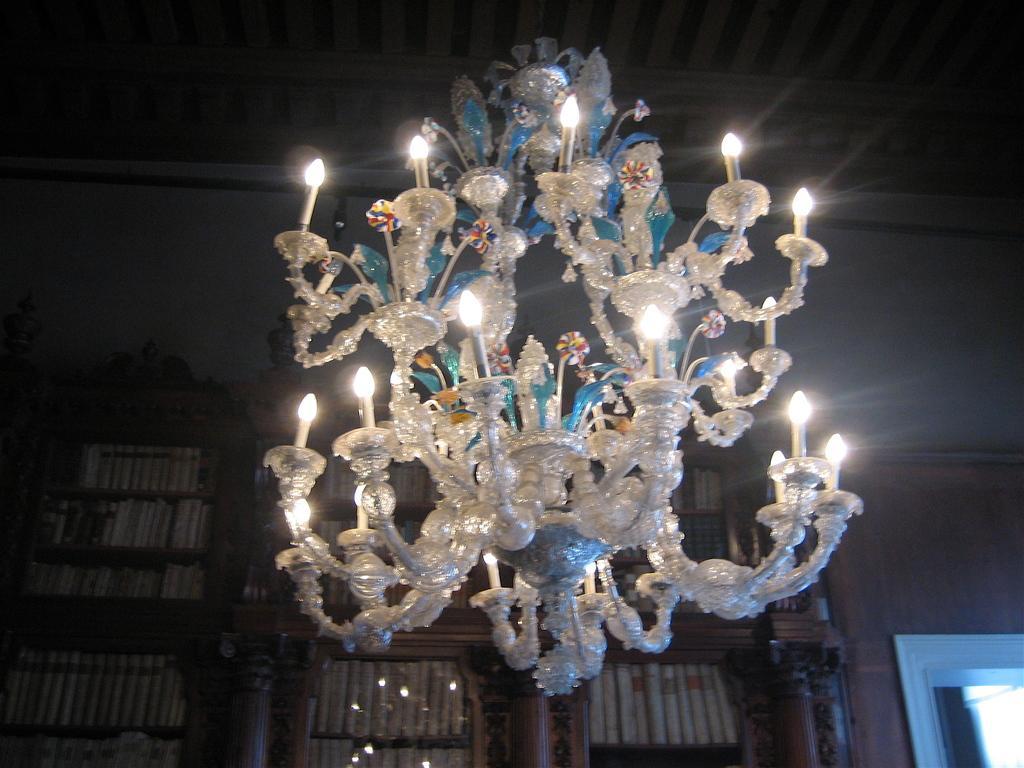In one or two sentences, can you explain what this image depicts? In the picture I can see a chandelier attached to the ceiling, objects in cupboards and a wall. 